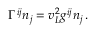<formula> <loc_0><loc_0><loc_500><loc_500>\Gamma ^ { i j } n _ { j } = v _ { L } ^ { 2 } g ^ { i j } n _ { j } \, .</formula> 